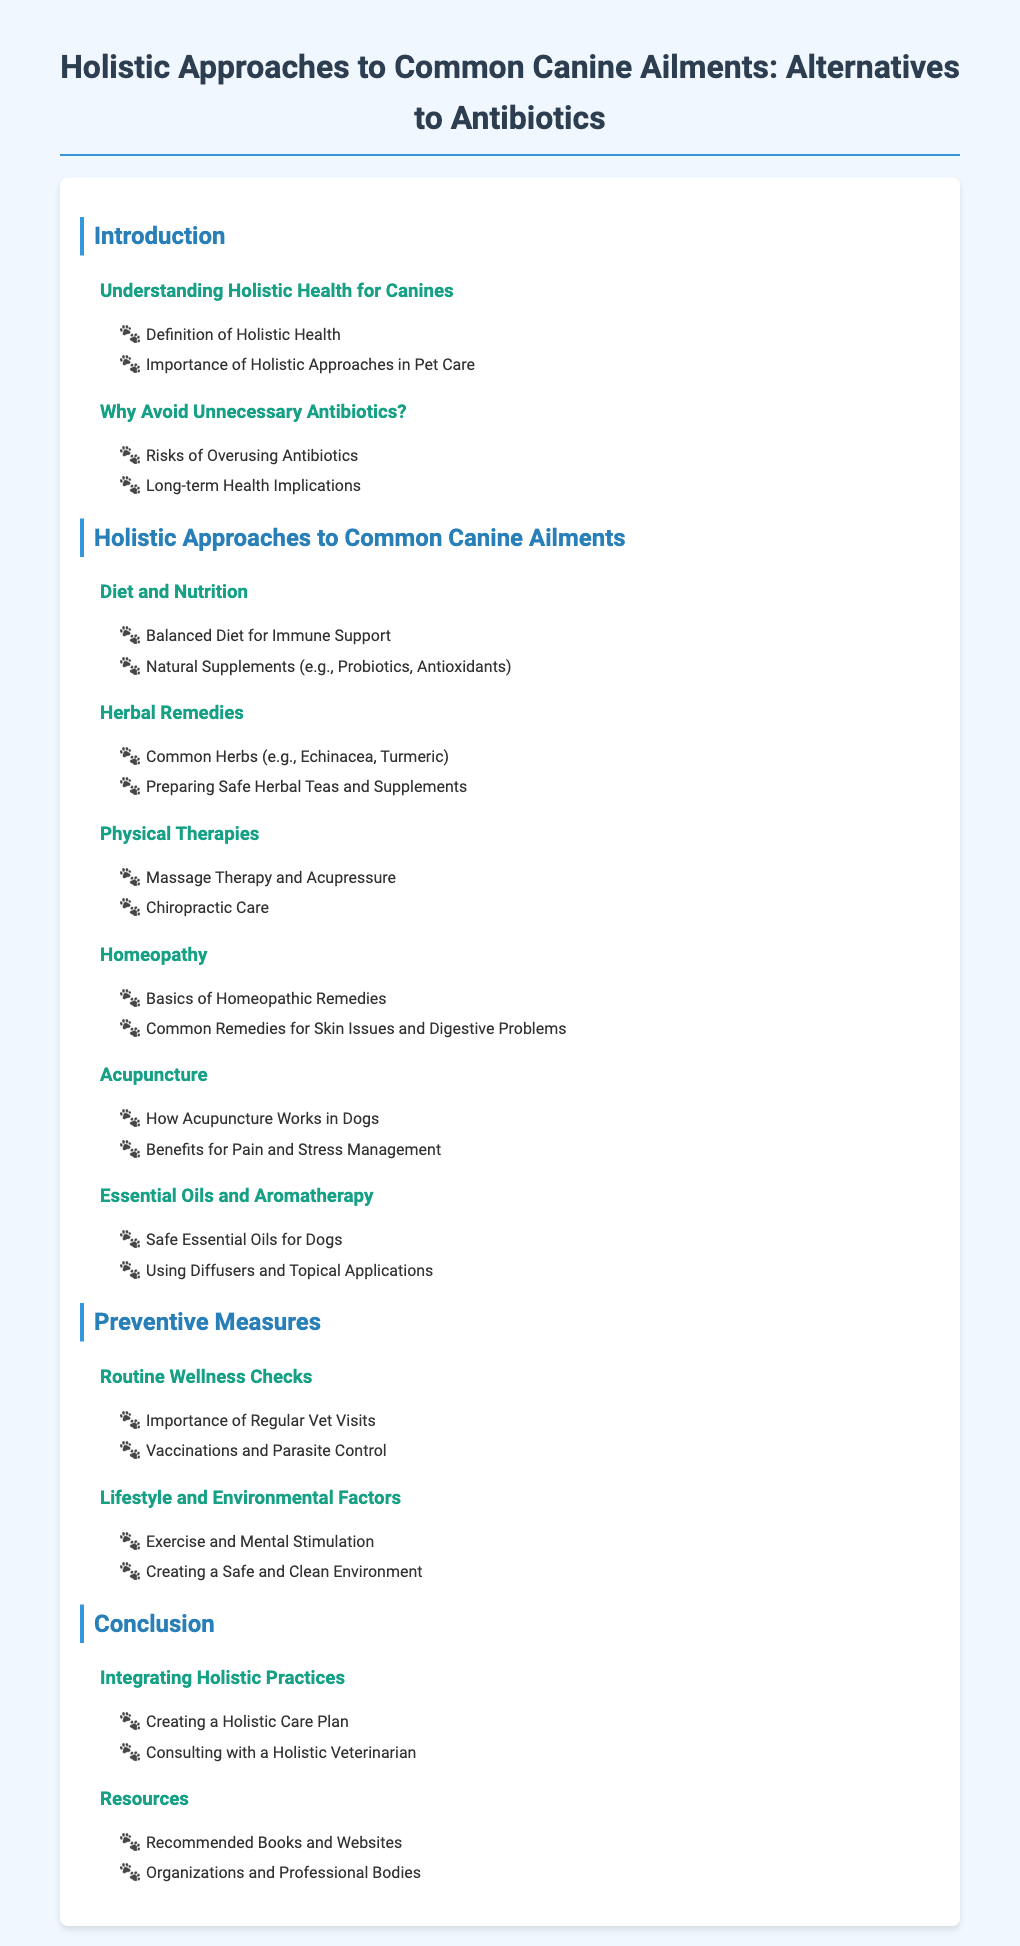what is the title of the document? The title is the main heading of the document, which summarizes its purpose.
Answer: Holistic Approaches to Common Canine Ailments: Alternatives to Antibiotics what section discusses the importance of holistic health? This section is found in the first part of the introduction.
Answer: Understanding Holistic Health for Canines how many common herbal remedies are mentioned? The section lists two specific herbs under herbal remedies.
Answer: 2 what is a key benefit of acupuncture for dogs? This information is provided under the acupuncture subsection.
Answer: Pain and Stress Management what preventive measure is important for canine health? This is outlined as part of the preventive measures section.
Answer: Routine Wellness Checks who should you consult for creating a holistic care plan? This advice is given in the conclusion section regarding veterinary consultation.
Answer: Holistic Veterinarian what type of therapy involves massage and acupressure? This therapy is mentioned as part of physical therapies in the document.
Answer: Physical Therapies what are two natural supplements mentioned for diet? The diet section lists these supplements specifically.
Answer: Probiotics, Antioxidants 